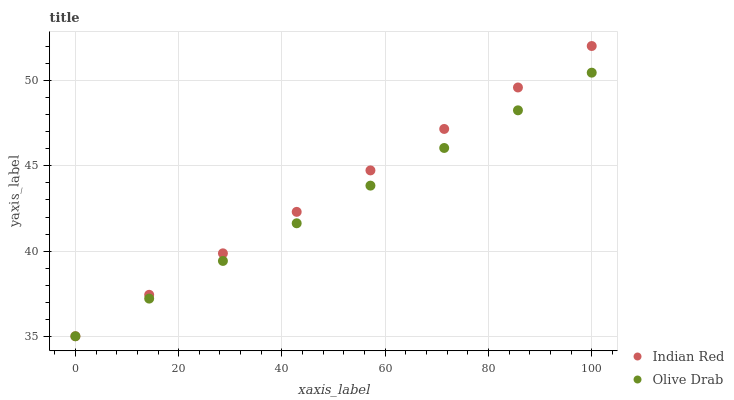Does Olive Drab have the minimum area under the curve?
Answer yes or no. Yes. Does Indian Red have the maximum area under the curve?
Answer yes or no. Yes. Does Indian Red have the minimum area under the curve?
Answer yes or no. No. Is Olive Drab the smoothest?
Answer yes or no. Yes. Is Indian Red the roughest?
Answer yes or no. Yes. Is Indian Red the smoothest?
Answer yes or no. No. Does Olive Drab have the lowest value?
Answer yes or no. Yes. Does Indian Red have the highest value?
Answer yes or no. Yes. Does Olive Drab intersect Indian Red?
Answer yes or no. Yes. Is Olive Drab less than Indian Red?
Answer yes or no. No. Is Olive Drab greater than Indian Red?
Answer yes or no. No. 